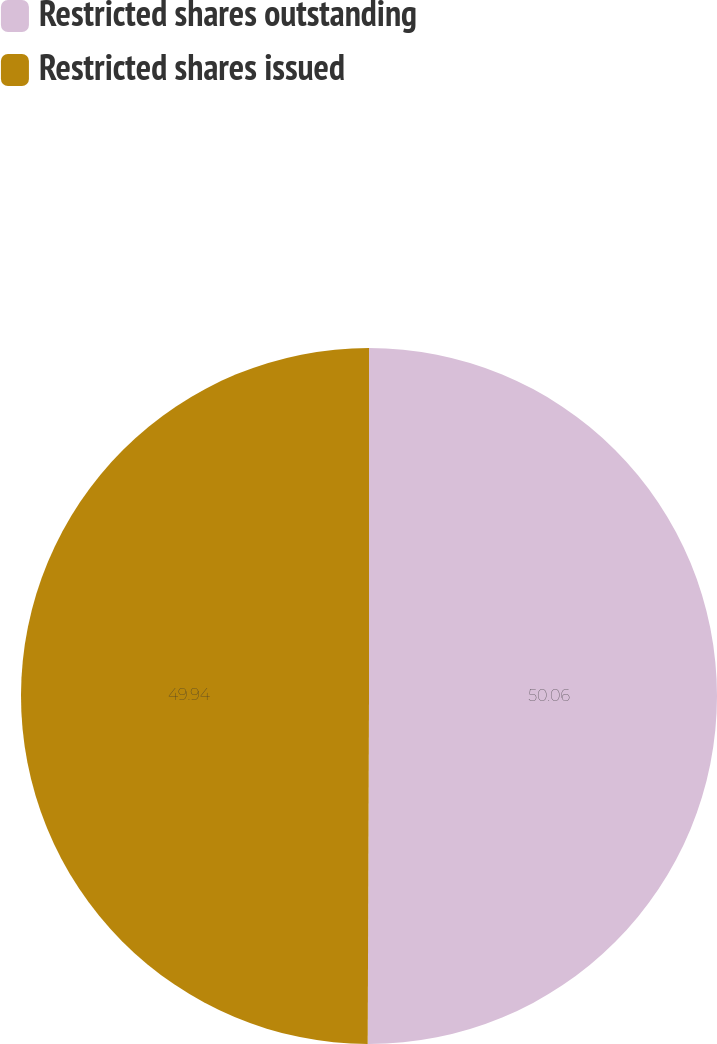Convert chart. <chart><loc_0><loc_0><loc_500><loc_500><pie_chart><fcel>Restricted shares outstanding<fcel>Restricted shares issued<nl><fcel>50.06%<fcel>49.94%<nl></chart> 